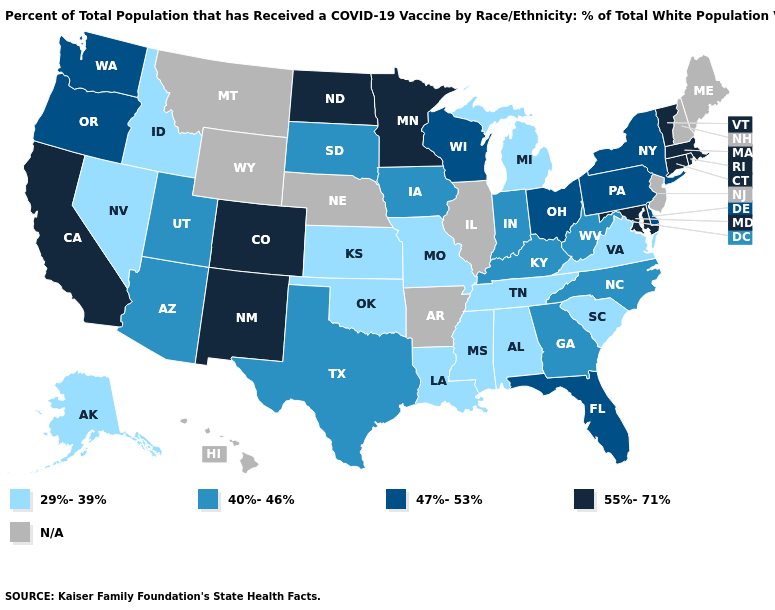What is the value of New Jersey?
Concise answer only. N/A. What is the lowest value in the USA?
Give a very brief answer. 29%-39%. Does Indiana have the lowest value in the MidWest?
Be succinct. No. What is the highest value in the West ?
Answer briefly. 55%-71%. Name the states that have a value in the range N/A?
Keep it brief. Arkansas, Hawaii, Illinois, Maine, Montana, Nebraska, New Hampshire, New Jersey, Wyoming. What is the lowest value in the USA?
Quick response, please. 29%-39%. What is the value of Oregon?
Give a very brief answer. 47%-53%. Which states have the lowest value in the MidWest?
Answer briefly. Kansas, Michigan, Missouri. Name the states that have a value in the range 40%-46%?
Concise answer only. Arizona, Georgia, Indiana, Iowa, Kentucky, North Carolina, South Dakota, Texas, Utah, West Virginia. What is the value of Rhode Island?
Short answer required. 55%-71%. Which states hav the highest value in the Northeast?
Quick response, please. Connecticut, Massachusetts, Rhode Island, Vermont. Among the states that border Colorado , which have the lowest value?
Write a very short answer. Kansas, Oklahoma. How many symbols are there in the legend?
Give a very brief answer. 5. What is the value of Utah?
Write a very short answer. 40%-46%. 